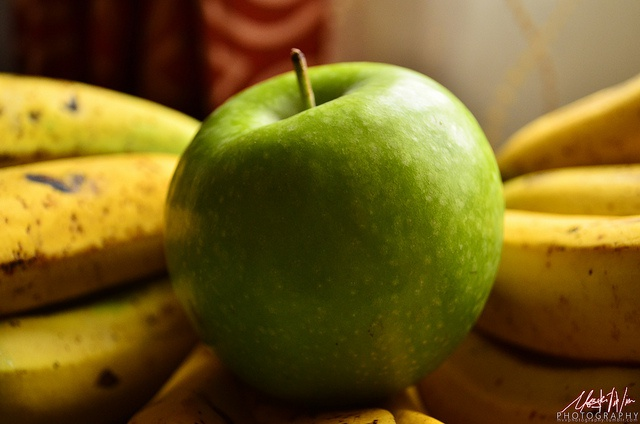Describe the objects in this image and their specific colors. I can see apple in black, darkgreen, olive, and khaki tones, banana in black, maroon, olive, and gold tones, banana in black, orange, maroon, and gold tones, banana in black, olive, and maroon tones, and banana in black, gold, and olive tones in this image. 